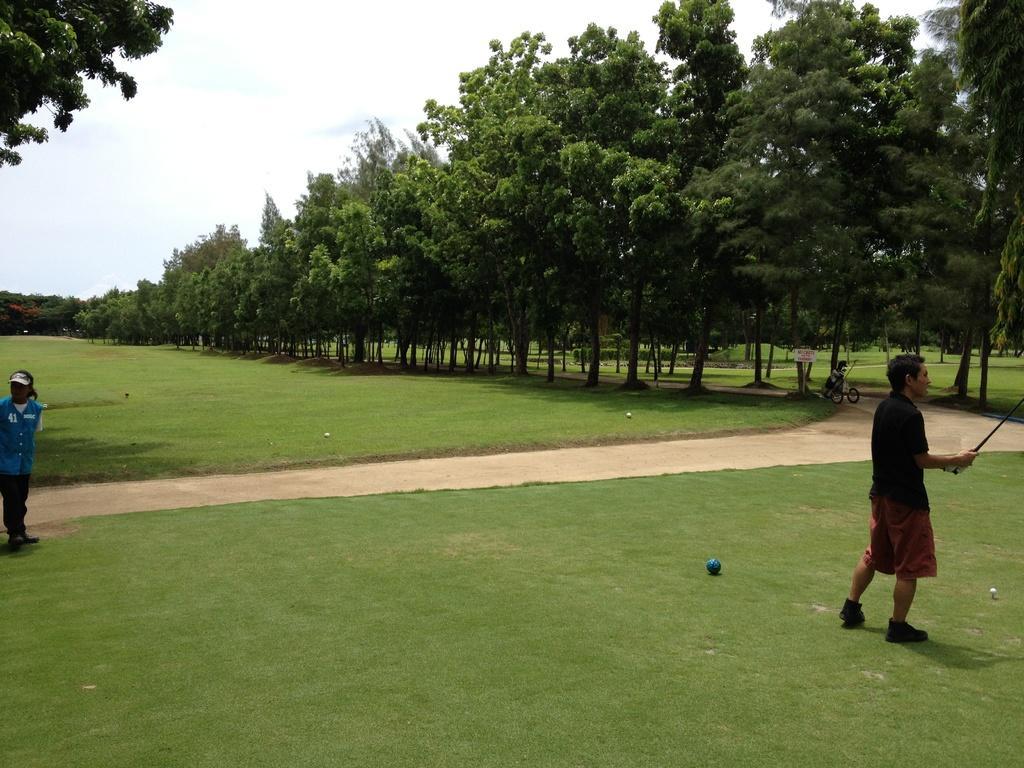Could you give a brief overview of what you see in this image? In this image, there is green color grass on the ground, at the right side there is a man standing and he is holding a stick, there is a ball on the grass, at the left side there is a person standing, there are some green color trees, at the top there is a sky. 